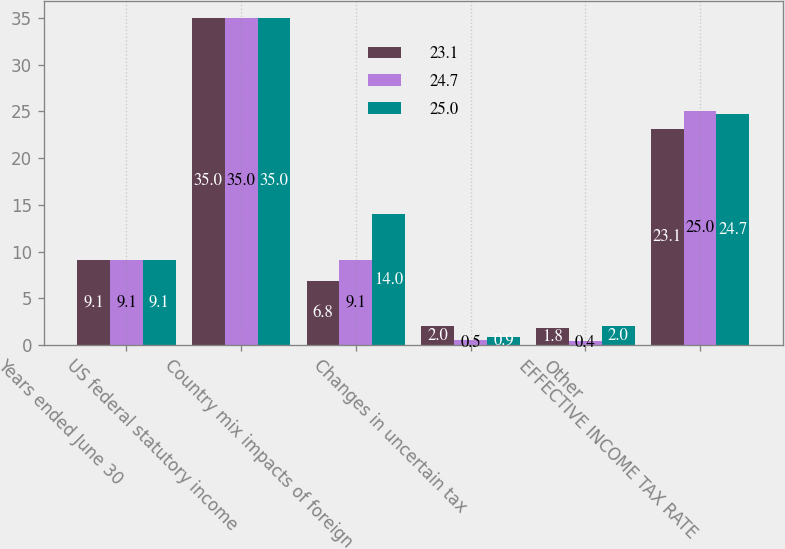Convert chart to OTSL. <chart><loc_0><loc_0><loc_500><loc_500><stacked_bar_chart><ecel><fcel>Years ended June 30<fcel>US federal statutory income<fcel>Country mix impacts of foreign<fcel>Changes in uncertain tax<fcel>Other<fcel>EFFECTIVE INCOME TAX RATE<nl><fcel>23.1<fcel>9.1<fcel>35<fcel>6.8<fcel>2<fcel>1.8<fcel>23.1<nl><fcel>24.7<fcel>9.1<fcel>35<fcel>9.1<fcel>0.5<fcel>0.4<fcel>25<nl><fcel>25<fcel>9.1<fcel>35<fcel>14<fcel>0.9<fcel>2<fcel>24.7<nl></chart> 